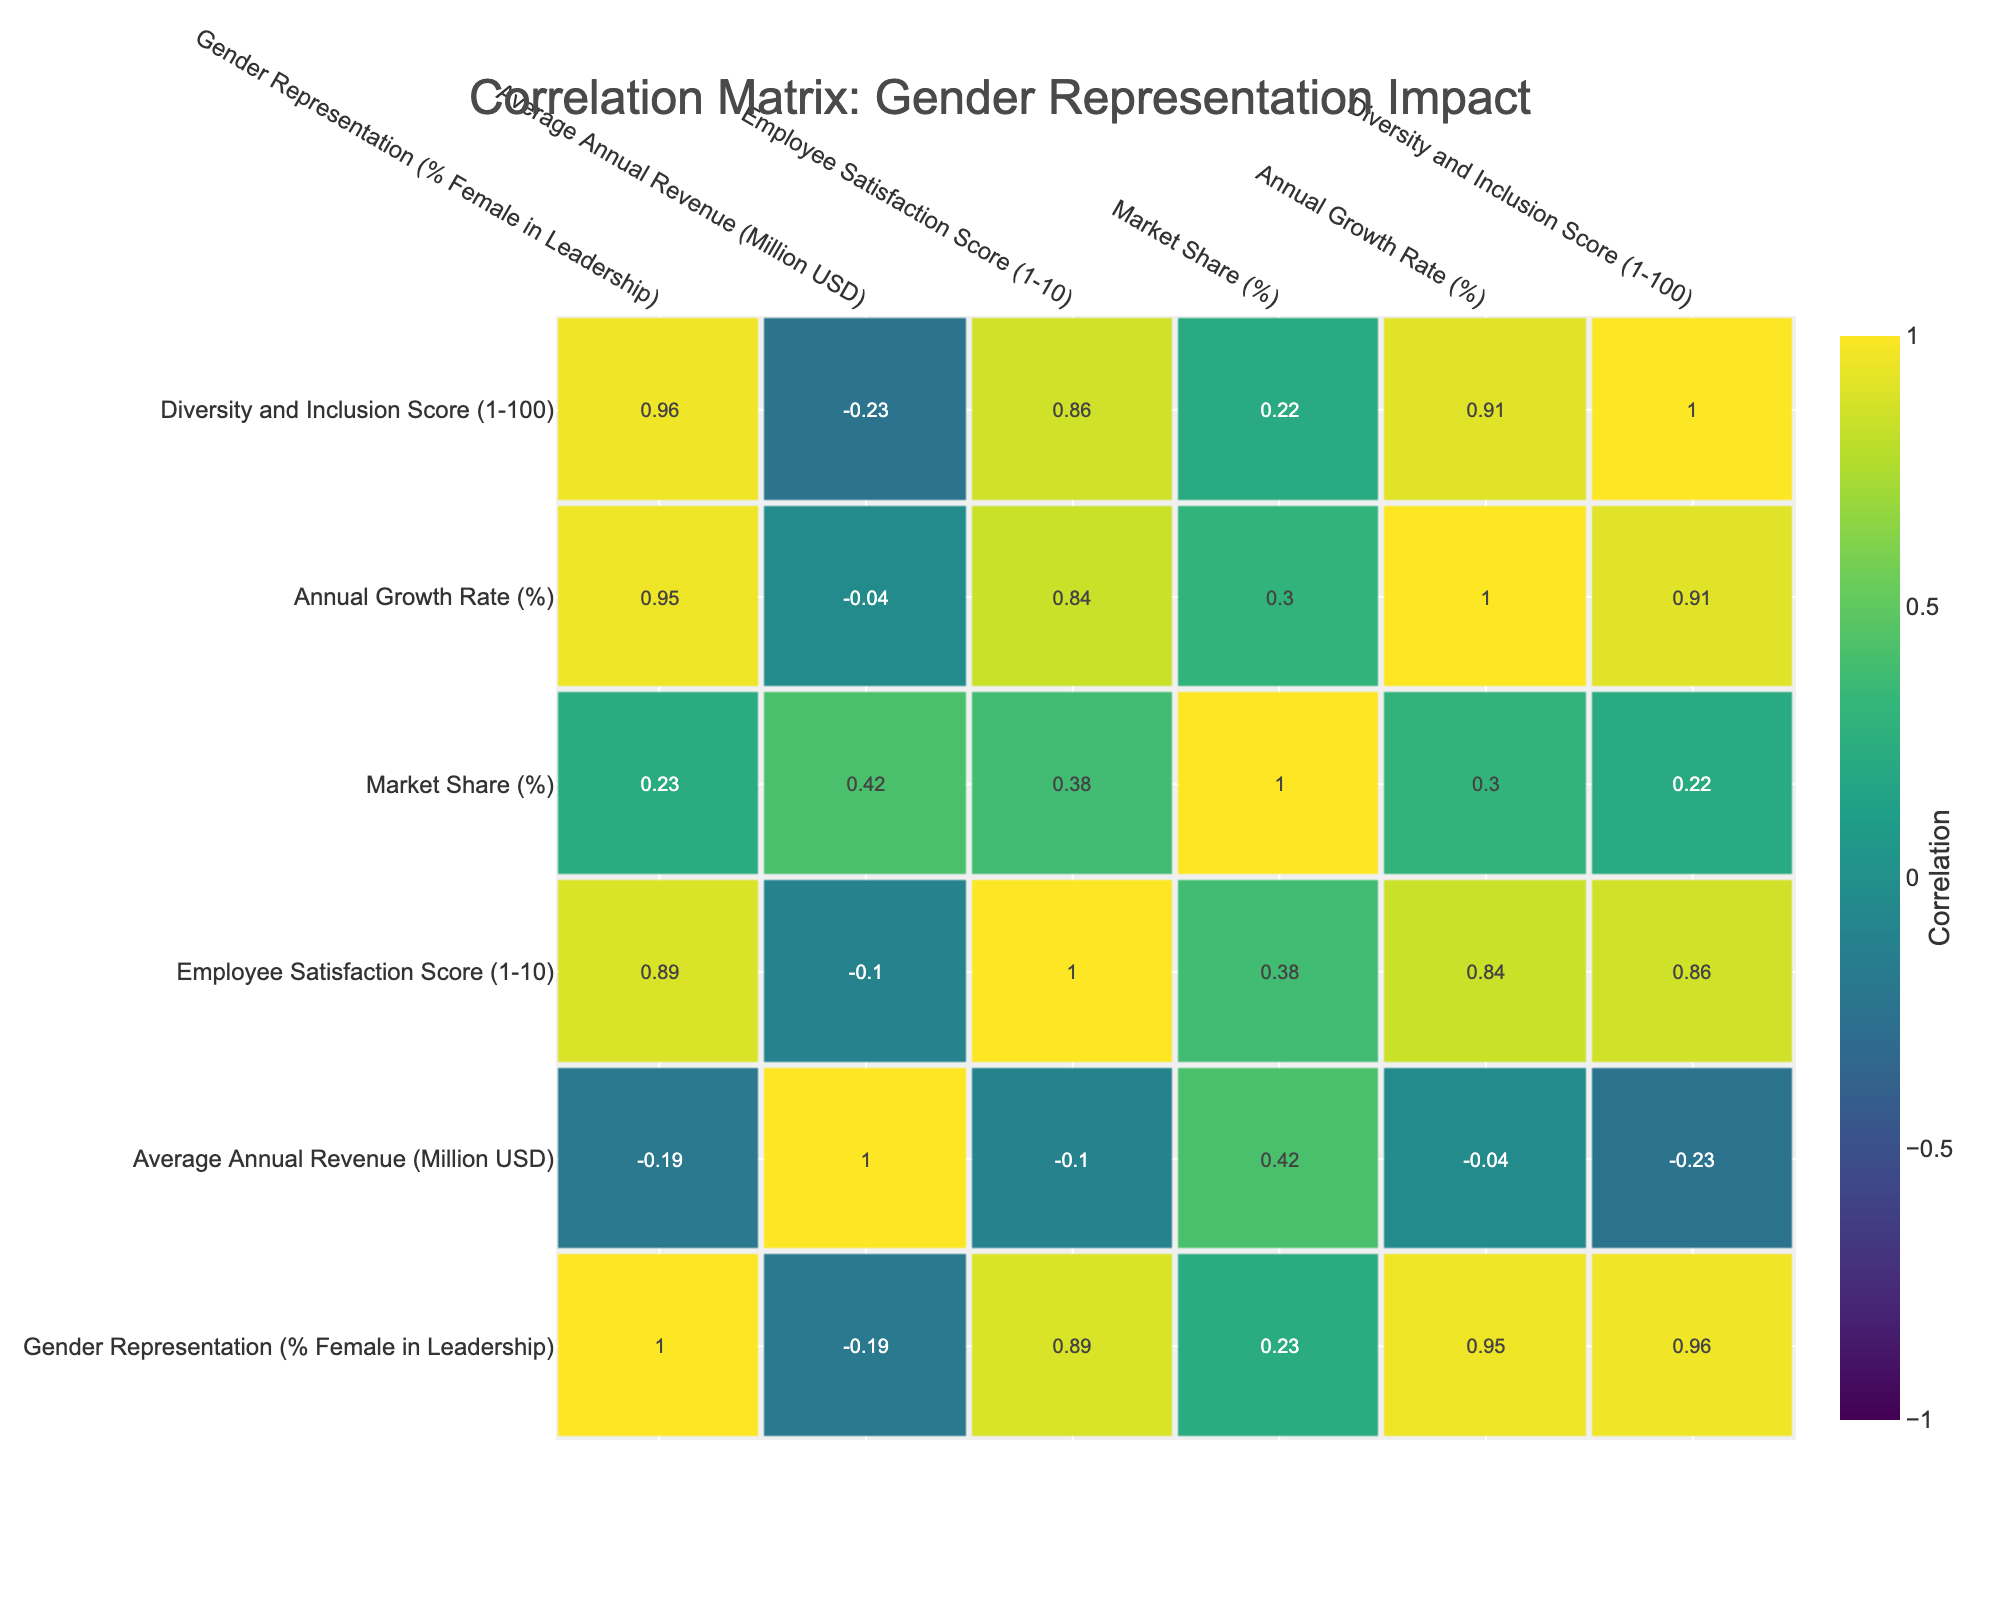What is the correlation between Gender Representation and Average Annual Revenue? From the correlation matrix, the correlation coefficient between "Gender Representation (% Female in Leadership)" and "Average Annual Revenue (Million USD)" is 0.24. This value indicates a weak positive correlation; as the percentage of female representation in leadership increases, the average annual revenue tends to increase slightly as well.
Answer: 0.24 Which company has the highest Market Share percentage, and what is that percentage? Looking at the table, "Transport Dynamics Corp." has the highest Market Share percentage at 30%.
Answer: 30% How does Employee Satisfaction Score relate to Gender Representation? The correlation between "Gender Representation (% Female in Leadership)" and "Employee Satisfaction Score (1-10)" is 0.38. This shows a moderate positive correlation, suggesting that higher gender representation may correlate with higher employee satisfaction.
Answer: 0.38 What is the difference in Annual Growth Rate between the company with the highest and lowest Gender Representation? The company with the highest Gender Representation is "Food & Wellness Brand" at 55% with an Annual Growth Rate of 9%, while the lowest is "Transport Dynamics Corp." at 20% with an Annual Growth Rate of 4%. The difference is 9% - 4% = 5%.
Answer: 5% Is it true that companies with a higher Diversity and Inclusion Score have a higher Average Annual Revenue? Examining the correlation between "Diversity and Inclusion Score (1-100)" and "Average Annual Revenue (Million USD)", the correlation is 0.38, suggesting a moderate positive relationship. Therefore, it can be inferred that higher scores in diversity and inclusion generally correspond to increased revenue. This supports the statement as true.
Answer: True What is the average Employee Satisfaction Score for the companies with more than 40% Female Representation in Leadership? The companies with more than 40% representation are "Global Retail Corp." (9), "Finance Group LLC" (8), "Sustainable Energy Co." (9), and "Food & Wellness Brand" (10). Summing these scores gives 9 + 8 + 9 + 10 = 36, and dividing by the 4 companies yields an average of 36/4 = 9.
Answer: 9 Which company shows the lowest Diversity and Inclusion Score, and how does it correlate with their Employee Satisfaction Score? "Transport Dynamics Corp." has the lowest Diversity and Inclusion Score of 65. The correlation with Employee Satisfaction Score is 0.20, indicating a weak positive relationship; hence, the lower the diversity score, the lower the employee satisfaction could potentially be, although this is a weak connection.
Answer: 65 What is the correlation coefficient between Market Share and Annual Growth Rate? The correlation coefficient between "Market Share (%)" and "Annual Growth Rate (%)" is 0.10. This indicates a very weak positive correlation, suggesting little relationship between these two variables.
Answer: 0.10 